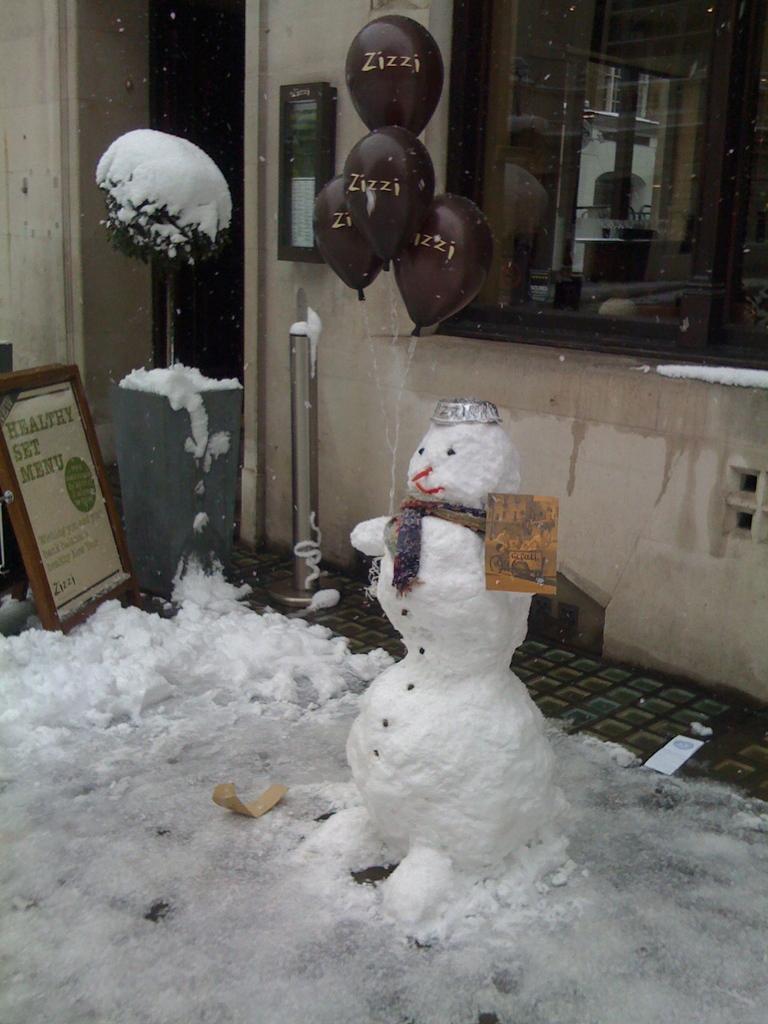Can you describe this image briefly? In this image we can see a snowman. Left side of the image one board and stand is there. Behind the snowman brown color balloons and wall is there. Bottom of the image land is covered with snow. Top right of the image window is present. 